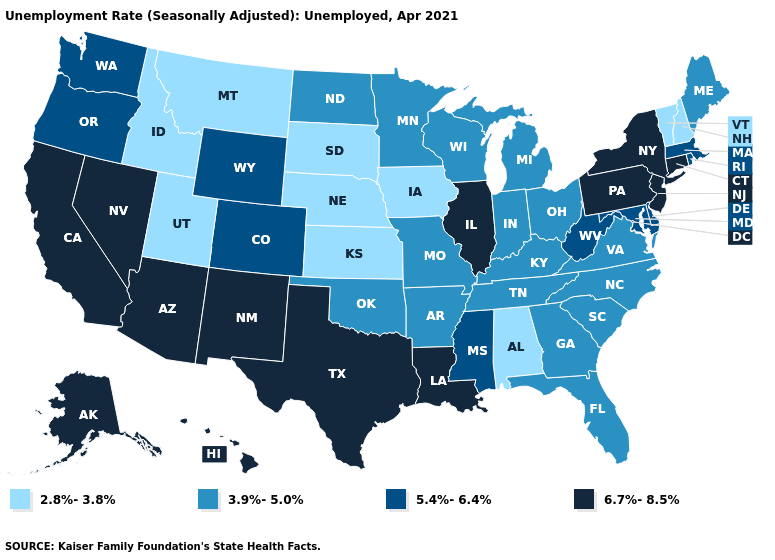What is the value of Florida?
Be succinct. 3.9%-5.0%. What is the value of Utah?
Concise answer only. 2.8%-3.8%. Name the states that have a value in the range 2.8%-3.8%?
Short answer required. Alabama, Idaho, Iowa, Kansas, Montana, Nebraska, New Hampshire, South Dakota, Utah, Vermont. Among the states that border Oregon , which have the lowest value?
Short answer required. Idaho. What is the value of Nevada?
Keep it brief. 6.7%-8.5%. Which states have the highest value in the USA?
Quick response, please. Alaska, Arizona, California, Connecticut, Hawaii, Illinois, Louisiana, Nevada, New Jersey, New Mexico, New York, Pennsylvania, Texas. Name the states that have a value in the range 2.8%-3.8%?
Be succinct. Alabama, Idaho, Iowa, Kansas, Montana, Nebraska, New Hampshire, South Dakota, Utah, Vermont. What is the value of Illinois?
Quick response, please. 6.7%-8.5%. Among the states that border North Carolina , which have the highest value?
Be succinct. Georgia, South Carolina, Tennessee, Virginia. What is the value of Nevada?
Quick response, please. 6.7%-8.5%. Does New York have the lowest value in the Northeast?
Write a very short answer. No. Among the states that border Colorado , does Kansas have the highest value?
Concise answer only. No. Does Mississippi have a higher value than Missouri?
Keep it brief. Yes. What is the highest value in states that border Virginia?
Give a very brief answer. 5.4%-6.4%. Does Oregon have the highest value in the West?
Short answer required. No. 